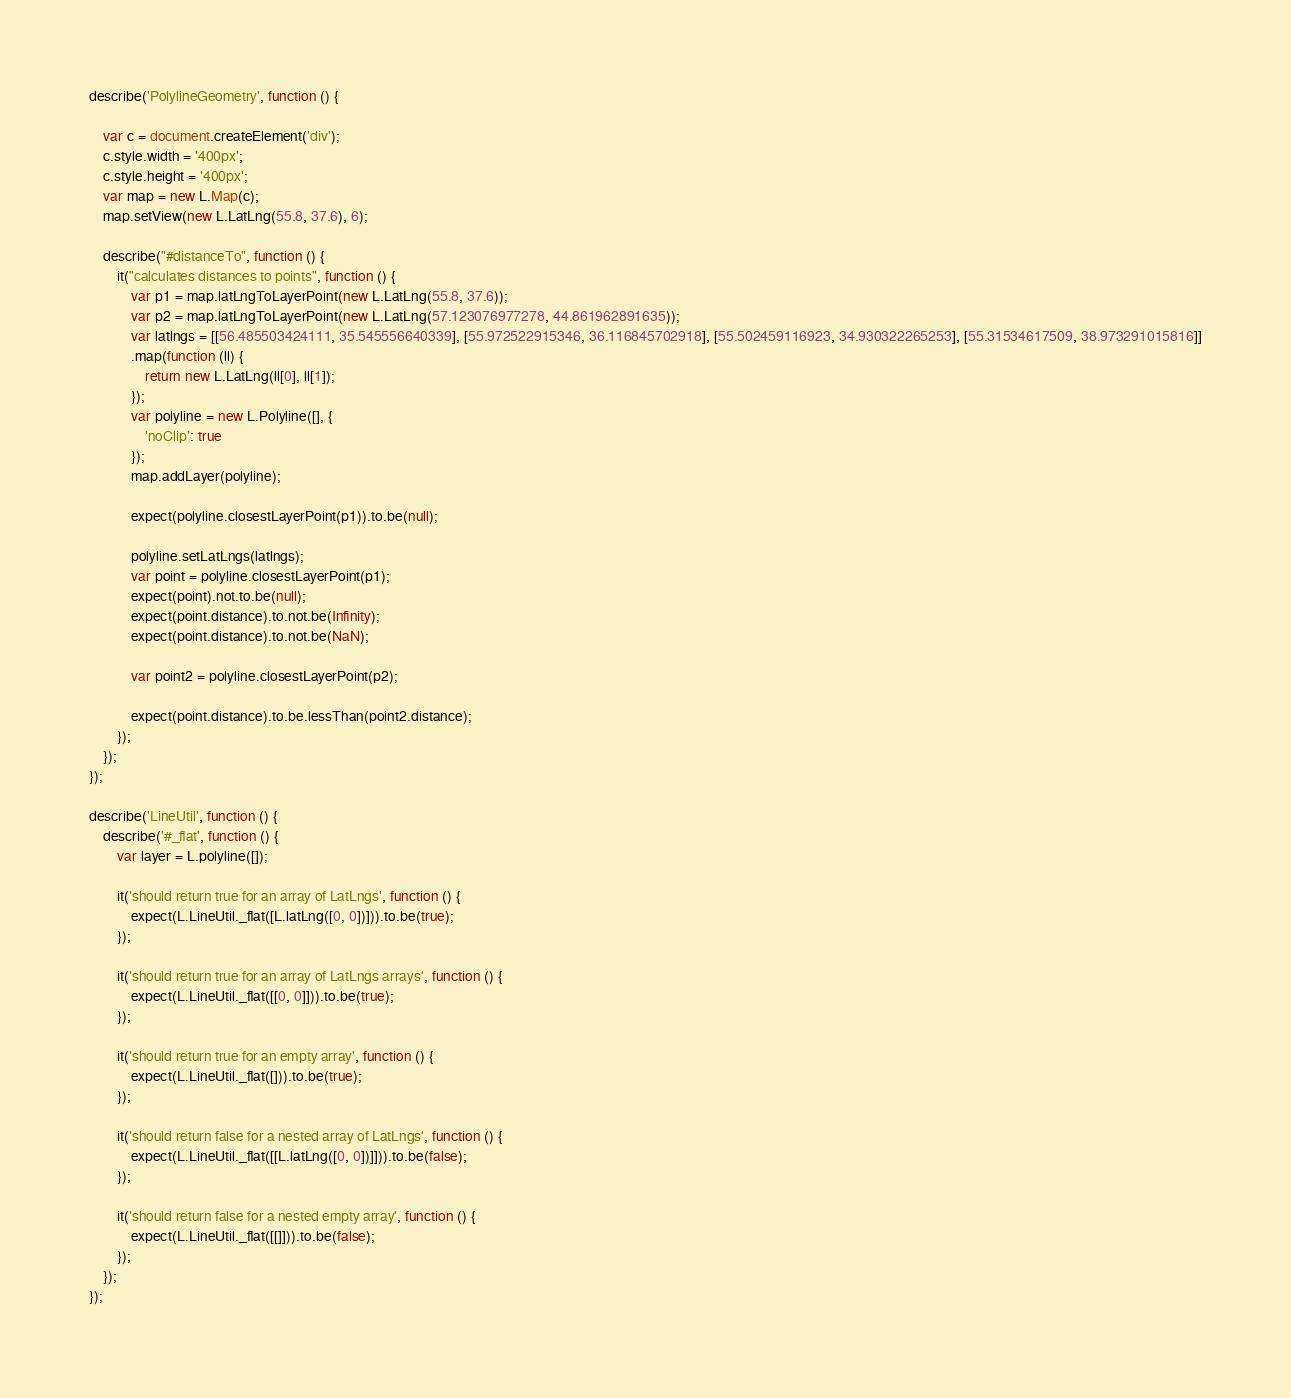<code> <loc_0><loc_0><loc_500><loc_500><_JavaScript_>describe('PolylineGeometry', function () {

	var c = document.createElement('div');
	c.style.width = '400px';
	c.style.height = '400px';
	var map = new L.Map(c);
	map.setView(new L.LatLng(55.8, 37.6), 6);

	describe("#distanceTo", function () {
		it("calculates distances to points", function () {
			var p1 = map.latLngToLayerPoint(new L.LatLng(55.8, 37.6));
			var p2 = map.latLngToLayerPoint(new L.LatLng(57.123076977278, 44.861962891635));
			var latlngs = [[56.485503424111, 35.545556640339], [55.972522915346, 36.116845702918], [55.502459116923, 34.930322265253], [55.31534617509, 38.973291015816]]
			.map(function (ll) {
				return new L.LatLng(ll[0], ll[1]);
			});
			var polyline = new L.Polyline([], {
				'noClip': true
			});
			map.addLayer(polyline);

			expect(polyline.closestLayerPoint(p1)).to.be(null);

			polyline.setLatLngs(latlngs);
			var point = polyline.closestLayerPoint(p1);
			expect(point).not.to.be(null);
			expect(point.distance).to.not.be(Infinity);
			expect(point.distance).to.not.be(NaN);

			var point2 = polyline.closestLayerPoint(p2);

			expect(point.distance).to.be.lessThan(point2.distance);
		});
	});
});

describe('LineUtil', function () {
	describe('#_flat', function () {
		var layer = L.polyline([]);

		it('should return true for an array of LatLngs', function () {
			expect(L.LineUtil._flat([L.latLng([0, 0])])).to.be(true);
		});

		it('should return true for an array of LatLngs arrays', function () {
			expect(L.LineUtil._flat([[0, 0]])).to.be(true);
		});

		it('should return true for an empty array', function () {
			expect(L.LineUtil._flat([])).to.be(true);
		});

		it('should return false for a nested array of LatLngs', function () {
			expect(L.LineUtil._flat([[L.latLng([0, 0])]])).to.be(false);
		});

		it('should return false for a nested empty array', function () {
			expect(L.LineUtil._flat([[]])).to.be(false);
		});
	});
});
</code> 